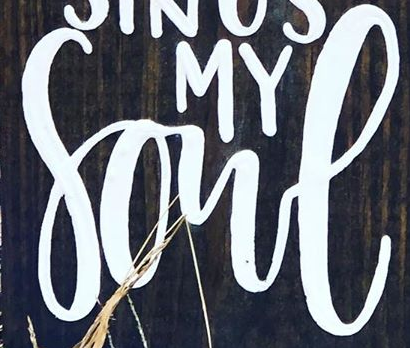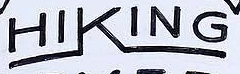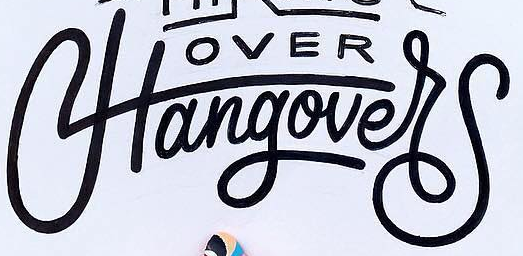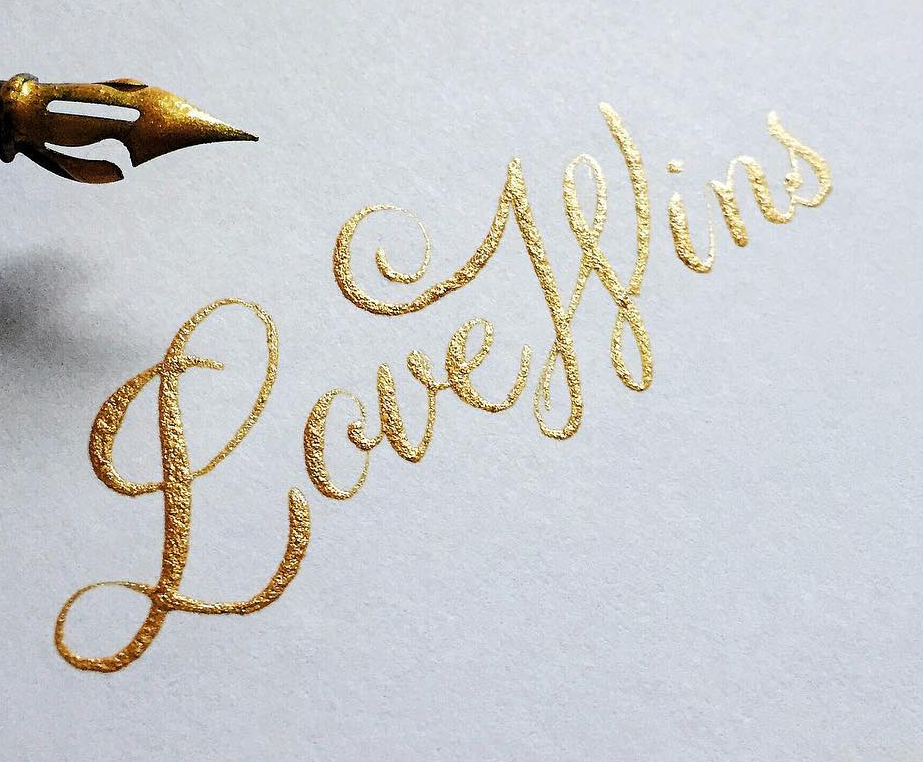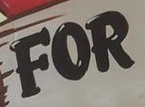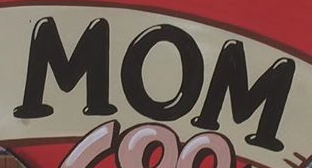What words can you see in these images in sequence, separated by a semicolon? Sone; HIKING; Hangover; LoveWins; FOR; MOM 